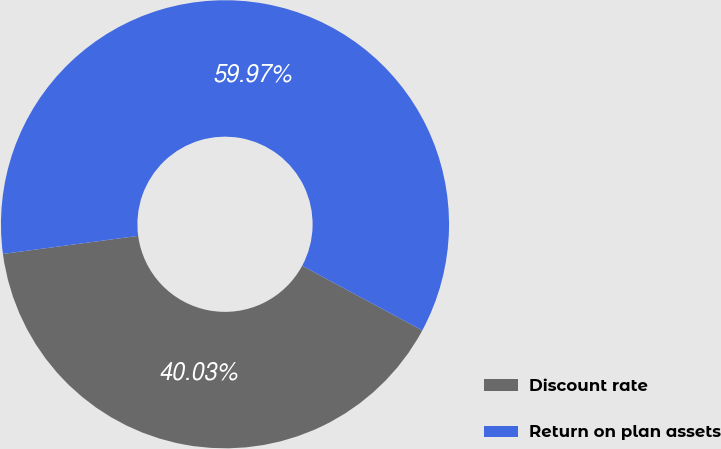Convert chart to OTSL. <chart><loc_0><loc_0><loc_500><loc_500><pie_chart><fcel>Discount rate<fcel>Return on plan assets<nl><fcel>40.03%<fcel>59.97%<nl></chart> 